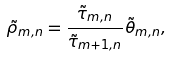<formula> <loc_0><loc_0><loc_500><loc_500>\tilde { \rho } _ { m , n } = \frac { \tilde { \tau } _ { m , n } } { \tilde { \tau } _ { m + 1 , n } } \tilde { \theta } _ { m , n } ,</formula> 